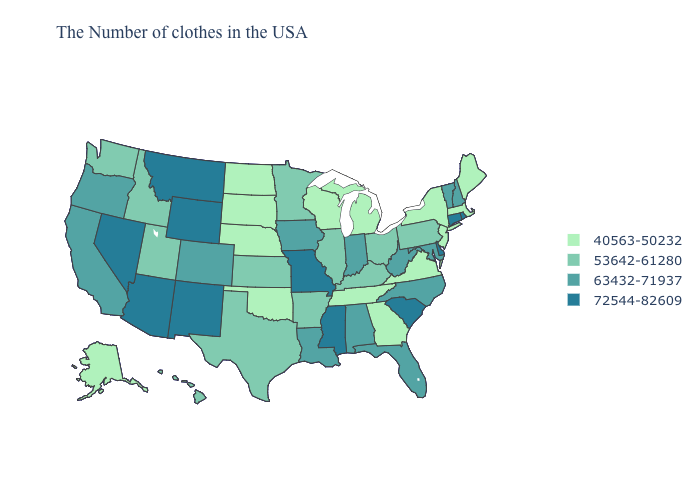Is the legend a continuous bar?
Concise answer only. No. Which states hav the highest value in the West?
Keep it brief. Wyoming, New Mexico, Montana, Arizona, Nevada. Does the map have missing data?
Answer briefly. No. What is the lowest value in the Northeast?
Answer briefly. 40563-50232. Name the states that have a value in the range 72544-82609?
Quick response, please. Rhode Island, Connecticut, Delaware, South Carolina, Mississippi, Missouri, Wyoming, New Mexico, Montana, Arizona, Nevada. Among the states that border Oregon , which have the lowest value?
Quick response, please. Idaho, Washington. What is the highest value in the USA?
Concise answer only. 72544-82609. How many symbols are there in the legend?
Concise answer only. 4. What is the highest value in the USA?
Answer briefly. 72544-82609. Is the legend a continuous bar?
Write a very short answer. No. Does the map have missing data?
Be succinct. No. What is the value of North Dakota?
Be succinct. 40563-50232. Which states have the highest value in the USA?
Quick response, please. Rhode Island, Connecticut, Delaware, South Carolina, Mississippi, Missouri, Wyoming, New Mexico, Montana, Arizona, Nevada. Does Idaho have a lower value than Kansas?
Give a very brief answer. No. Name the states that have a value in the range 63432-71937?
Concise answer only. New Hampshire, Vermont, Maryland, North Carolina, West Virginia, Florida, Indiana, Alabama, Louisiana, Iowa, Colorado, California, Oregon. 